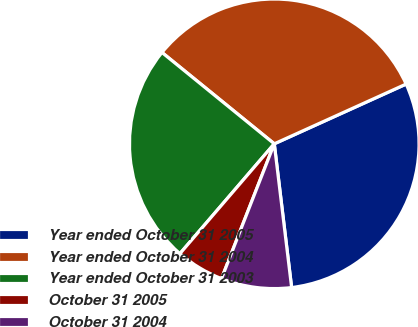Convert chart to OTSL. <chart><loc_0><loc_0><loc_500><loc_500><pie_chart><fcel>Year ended October 31 2005<fcel>Year ended October 31 2004<fcel>Year ended October 31 2003<fcel>October 31 2005<fcel>October 31 2004<nl><fcel>29.86%<fcel>32.36%<fcel>24.57%<fcel>5.36%<fcel>7.85%<nl></chart> 